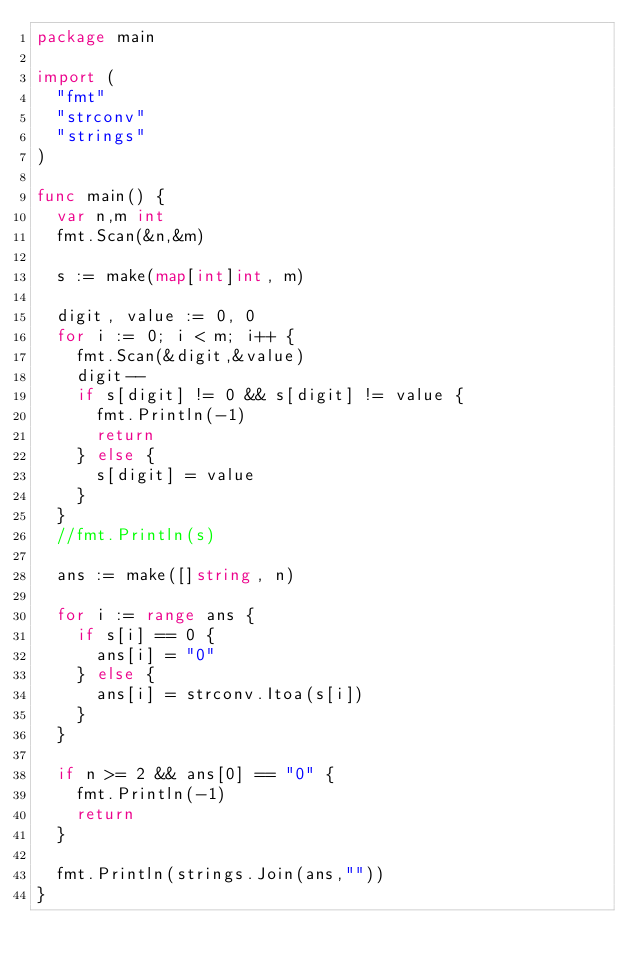Convert code to text. <code><loc_0><loc_0><loc_500><loc_500><_Go_>package main

import (
	"fmt"
	"strconv"
	"strings"
)

func main() {
	var n,m int
	fmt.Scan(&n,&m)
	
	s := make(map[int]int, m)
	
	digit, value := 0, 0
	for i := 0; i < m; i++ {
		fmt.Scan(&digit,&value)
		digit--
		if s[digit] != 0 && s[digit] != value {
			fmt.Println(-1)
			return
		} else {
			s[digit] = value
		}
	}
	//fmt.Println(s)
	
	ans := make([]string, n)
	
	for i := range ans {
		if s[i] == 0 {
			ans[i] = "0"
		} else {
			ans[i] = strconv.Itoa(s[i])
		}
	}
	
	if n >= 2 && ans[0] == "0" {
		fmt.Println(-1)
		return
	}
	
	fmt.Println(strings.Join(ans,""))
}</code> 